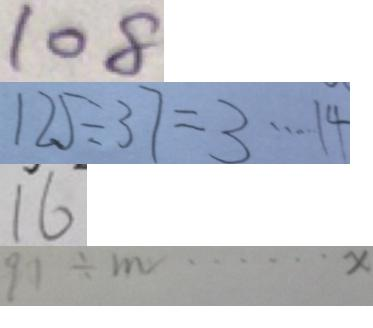<formula> <loc_0><loc_0><loc_500><loc_500>1 0 8 
 1 2 5 \div 3 7 = 3 \cdots 1 4 
 1 6 
 9 1 \div m = \cdots x</formula> 